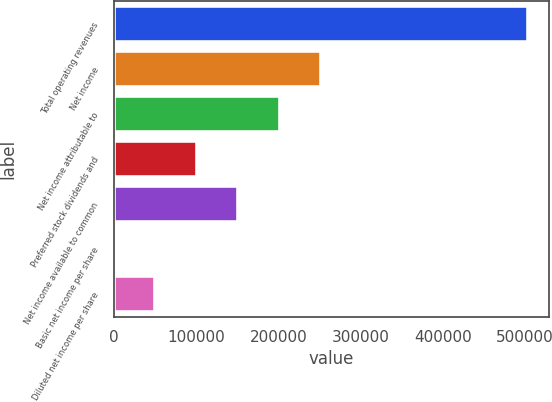<chart> <loc_0><loc_0><loc_500><loc_500><bar_chart><fcel>Total operating revenues<fcel>Net income<fcel>Net income attributable to<fcel>Preferred stock dividends and<fcel>Net income available to common<fcel>Basic net income per share<fcel>Diluted net income per share<nl><fcel>504199<fcel>252100<fcel>201680<fcel>100840<fcel>151260<fcel>0.27<fcel>50420.1<nl></chart> 